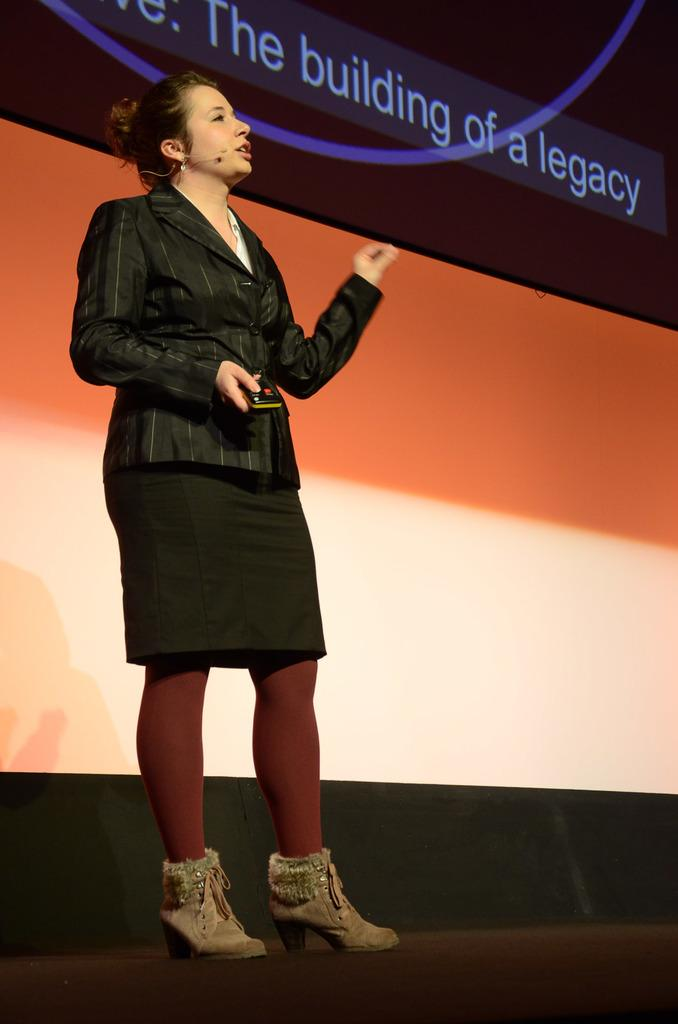What can be seen in the image? There is a person in the image. What is the person doing in the image? The person is holding an object and standing. What is visible beneath the person's feet? The ground is visible in the image. What can be seen behind the person? There is a background in the image. What is written or displayed at the top of the image? There is some text at the top of the image. What type of insect can be seen crawling on the person's arm in the image? There is no insect present on the person's arm in the image. What type of cast is visible on the person's leg in the image? There is no cast visible on the person's leg in the image. 